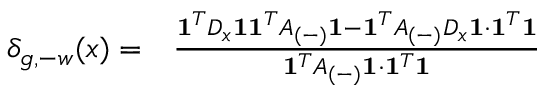Convert formula to latex. <formula><loc_0><loc_0><loc_500><loc_500>\begin{array} { r l } { \delta _ { g , - w } ( x ) = } & { \frac { 1 ^ { T } D _ { x } 1 1 ^ { T } A _ { ( - ) } 1 - 1 ^ { T } A _ { ( - ) } D _ { x } 1 \cdot 1 ^ { T } 1 } { 1 ^ { T } A _ { ( - ) } 1 \cdot 1 ^ { T } 1 } } \end{array}</formula> 